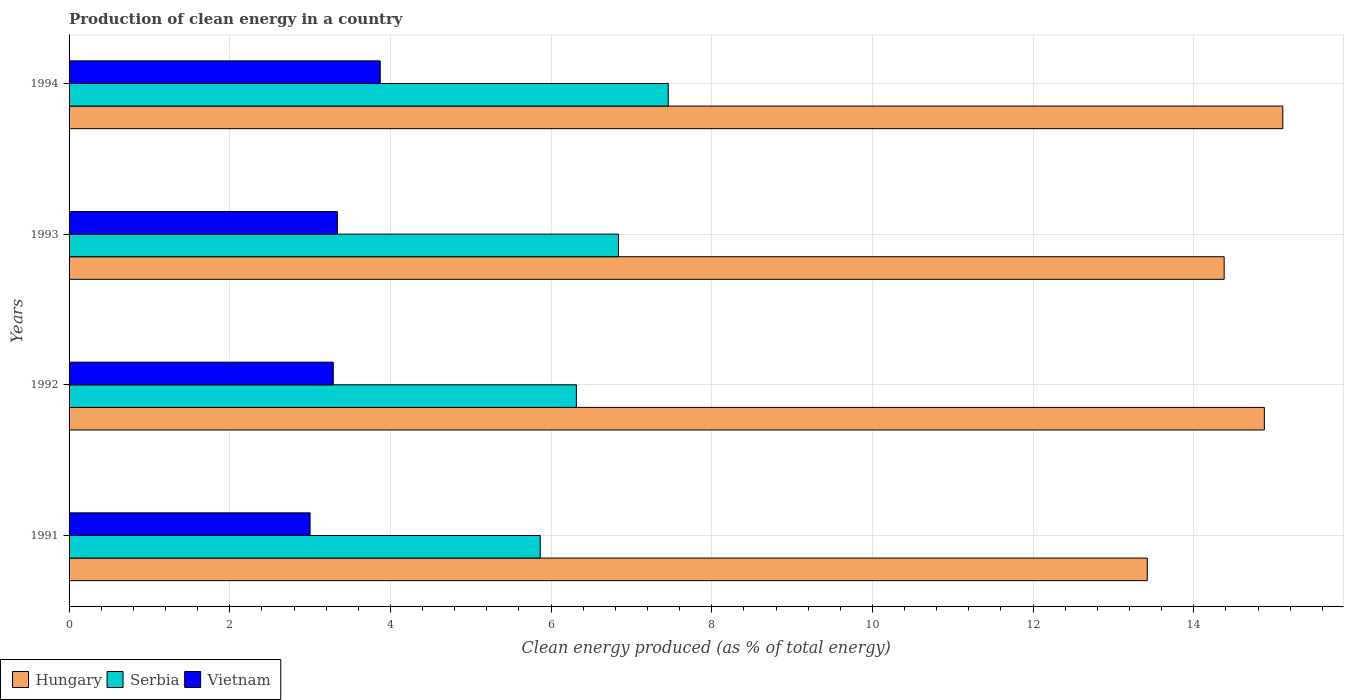Are the number of bars per tick equal to the number of legend labels?
Ensure brevity in your answer.  Yes. Are the number of bars on each tick of the Y-axis equal?
Ensure brevity in your answer.  Yes. How many bars are there on the 4th tick from the bottom?
Ensure brevity in your answer.  3. In how many cases, is the number of bars for a given year not equal to the number of legend labels?
Offer a terse response. 0. What is the percentage of clean energy produced in Serbia in 1992?
Provide a succinct answer. 6.32. Across all years, what is the maximum percentage of clean energy produced in Hungary?
Make the answer very short. 15.11. Across all years, what is the minimum percentage of clean energy produced in Serbia?
Make the answer very short. 5.87. What is the total percentage of clean energy produced in Vietnam in the graph?
Make the answer very short. 13.5. What is the difference between the percentage of clean energy produced in Serbia in 1992 and that in 1993?
Offer a very short reply. -0.52. What is the difference between the percentage of clean energy produced in Vietnam in 1992 and the percentage of clean energy produced in Serbia in 1993?
Offer a terse response. -3.55. What is the average percentage of clean energy produced in Vietnam per year?
Offer a terse response. 3.38. In the year 1993, what is the difference between the percentage of clean energy produced in Serbia and percentage of clean energy produced in Hungary?
Provide a short and direct response. -7.54. What is the ratio of the percentage of clean energy produced in Serbia in 1991 to that in 1992?
Your answer should be very brief. 0.93. Is the difference between the percentage of clean energy produced in Serbia in 1992 and 1993 greater than the difference between the percentage of clean energy produced in Hungary in 1992 and 1993?
Your answer should be very brief. No. What is the difference between the highest and the second highest percentage of clean energy produced in Hungary?
Your response must be concise. 0.23. What is the difference between the highest and the lowest percentage of clean energy produced in Serbia?
Keep it short and to the point. 1.59. Is the sum of the percentage of clean energy produced in Serbia in 1992 and 1993 greater than the maximum percentage of clean energy produced in Vietnam across all years?
Make the answer very short. Yes. What does the 1st bar from the top in 1992 represents?
Offer a terse response. Vietnam. What does the 1st bar from the bottom in 1991 represents?
Offer a very short reply. Hungary. Is it the case that in every year, the sum of the percentage of clean energy produced in Serbia and percentage of clean energy produced in Vietnam is greater than the percentage of clean energy produced in Hungary?
Provide a succinct answer. No. Are all the bars in the graph horizontal?
Ensure brevity in your answer.  Yes. How many years are there in the graph?
Your answer should be compact. 4. Are the values on the major ticks of X-axis written in scientific E-notation?
Offer a very short reply. No. Does the graph contain any zero values?
Offer a terse response. No. How many legend labels are there?
Provide a short and direct response. 3. How are the legend labels stacked?
Give a very brief answer. Horizontal. What is the title of the graph?
Your response must be concise. Production of clean energy in a country. Does "Brazil" appear as one of the legend labels in the graph?
Provide a succinct answer. No. What is the label or title of the X-axis?
Your answer should be compact. Clean energy produced (as % of total energy). What is the label or title of the Y-axis?
Offer a terse response. Years. What is the Clean energy produced (as % of total energy) of Hungary in 1991?
Offer a very short reply. 13.42. What is the Clean energy produced (as % of total energy) of Serbia in 1991?
Keep it short and to the point. 5.87. What is the Clean energy produced (as % of total energy) of Vietnam in 1991?
Keep it short and to the point. 3. What is the Clean energy produced (as % of total energy) in Hungary in 1992?
Ensure brevity in your answer.  14.88. What is the Clean energy produced (as % of total energy) in Serbia in 1992?
Offer a terse response. 6.32. What is the Clean energy produced (as % of total energy) of Vietnam in 1992?
Keep it short and to the point. 3.29. What is the Clean energy produced (as % of total energy) of Hungary in 1993?
Make the answer very short. 14.38. What is the Clean energy produced (as % of total energy) of Serbia in 1993?
Your response must be concise. 6.84. What is the Clean energy produced (as % of total energy) of Vietnam in 1993?
Your response must be concise. 3.34. What is the Clean energy produced (as % of total energy) in Hungary in 1994?
Provide a succinct answer. 15.11. What is the Clean energy produced (as % of total energy) in Serbia in 1994?
Ensure brevity in your answer.  7.46. What is the Clean energy produced (as % of total energy) in Vietnam in 1994?
Ensure brevity in your answer.  3.87. Across all years, what is the maximum Clean energy produced (as % of total energy) of Hungary?
Make the answer very short. 15.11. Across all years, what is the maximum Clean energy produced (as % of total energy) in Serbia?
Make the answer very short. 7.46. Across all years, what is the maximum Clean energy produced (as % of total energy) in Vietnam?
Your response must be concise. 3.87. Across all years, what is the minimum Clean energy produced (as % of total energy) of Hungary?
Your response must be concise. 13.42. Across all years, what is the minimum Clean energy produced (as % of total energy) of Serbia?
Your answer should be compact. 5.87. Across all years, what is the minimum Clean energy produced (as % of total energy) in Vietnam?
Provide a short and direct response. 3. What is the total Clean energy produced (as % of total energy) of Hungary in the graph?
Provide a short and direct response. 57.79. What is the total Clean energy produced (as % of total energy) of Serbia in the graph?
Your response must be concise. 26.48. What is the total Clean energy produced (as % of total energy) in Vietnam in the graph?
Keep it short and to the point. 13.5. What is the difference between the Clean energy produced (as % of total energy) of Hungary in 1991 and that in 1992?
Offer a very short reply. -1.46. What is the difference between the Clean energy produced (as % of total energy) in Serbia in 1991 and that in 1992?
Your response must be concise. -0.45. What is the difference between the Clean energy produced (as % of total energy) of Vietnam in 1991 and that in 1992?
Make the answer very short. -0.29. What is the difference between the Clean energy produced (as % of total energy) of Hungary in 1991 and that in 1993?
Your answer should be very brief. -0.96. What is the difference between the Clean energy produced (as % of total energy) in Serbia in 1991 and that in 1993?
Your answer should be compact. -0.97. What is the difference between the Clean energy produced (as % of total energy) of Vietnam in 1991 and that in 1993?
Your response must be concise. -0.34. What is the difference between the Clean energy produced (as % of total energy) in Hungary in 1991 and that in 1994?
Make the answer very short. -1.69. What is the difference between the Clean energy produced (as % of total energy) of Serbia in 1991 and that in 1994?
Your response must be concise. -1.59. What is the difference between the Clean energy produced (as % of total energy) in Vietnam in 1991 and that in 1994?
Ensure brevity in your answer.  -0.87. What is the difference between the Clean energy produced (as % of total energy) in Hungary in 1992 and that in 1993?
Offer a terse response. 0.5. What is the difference between the Clean energy produced (as % of total energy) of Serbia in 1992 and that in 1993?
Make the answer very short. -0.52. What is the difference between the Clean energy produced (as % of total energy) in Vietnam in 1992 and that in 1993?
Give a very brief answer. -0.05. What is the difference between the Clean energy produced (as % of total energy) of Hungary in 1992 and that in 1994?
Offer a terse response. -0.23. What is the difference between the Clean energy produced (as % of total energy) in Serbia in 1992 and that in 1994?
Provide a short and direct response. -1.14. What is the difference between the Clean energy produced (as % of total energy) of Vietnam in 1992 and that in 1994?
Your answer should be compact. -0.58. What is the difference between the Clean energy produced (as % of total energy) of Hungary in 1993 and that in 1994?
Keep it short and to the point. -0.73. What is the difference between the Clean energy produced (as % of total energy) of Serbia in 1993 and that in 1994?
Offer a terse response. -0.62. What is the difference between the Clean energy produced (as % of total energy) in Vietnam in 1993 and that in 1994?
Ensure brevity in your answer.  -0.53. What is the difference between the Clean energy produced (as % of total energy) of Hungary in 1991 and the Clean energy produced (as % of total energy) of Serbia in 1992?
Your response must be concise. 7.11. What is the difference between the Clean energy produced (as % of total energy) of Hungary in 1991 and the Clean energy produced (as % of total energy) of Vietnam in 1992?
Keep it short and to the point. 10.13. What is the difference between the Clean energy produced (as % of total energy) in Serbia in 1991 and the Clean energy produced (as % of total energy) in Vietnam in 1992?
Offer a very short reply. 2.58. What is the difference between the Clean energy produced (as % of total energy) of Hungary in 1991 and the Clean energy produced (as % of total energy) of Serbia in 1993?
Your answer should be very brief. 6.58. What is the difference between the Clean energy produced (as % of total energy) in Hungary in 1991 and the Clean energy produced (as % of total energy) in Vietnam in 1993?
Your answer should be very brief. 10.08. What is the difference between the Clean energy produced (as % of total energy) in Serbia in 1991 and the Clean energy produced (as % of total energy) in Vietnam in 1993?
Keep it short and to the point. 2.53. What is the difference between the Clean energy produced (as % of total energy) of Hungary in 1991 and the Clean energy produced (as % of total energy) of Serbia in 1994?
Offer a terse response. 5.96. What is the difference between the Clean energy produced (as % of total energy) in Hungary in 1991 and the Clean energy produced (as % of total energy) in Vietnam in 1994?
Ensure brevity in your answer.  9.55. What is the difference between the Clean energy produced (as % of total energy) of Serbia in 1991 and the Clean energy produced (as % of total energy) of Vietnam in 1994?
Make the answer very short. 1.99. What is the difference between the Clean energy produced (as % of total energy) in Hungary in 1992 and the Clean energy produced (as % of total energy) in Serbia in 1993?
Offer a very short reply. 8.04. What is the difference between the Clean energy produced (as % of total energy) of Hungary in 1992 and the Clean energy produced (as % of total energy) of Vietnam in 1993?
Make the answer very short. 11.54. What is the difference between the Clean energy produced (as % of total energy) in Serbia in 1992 and the Clean energy produced (as % of total energy) in Vietnam in 1993?
Keep it short and to the point. 2.98. What is the difference between the Clean energy produced (as % of total energy) of Hungary in 1992 and the Clean energy produced (as % of total energy) of Serbia in 1994?
Provide a short and direct response. 7.42. What is the difference between the Clean energy produced (as % of total energy) in Hungary in 1992 and the Clean energy produced (as % of total energy) in Vietnam in 1994?
Ensure brevity in your answer.  11.01. What is the difference between the Clean energy produced (as % of total energy) in Serbia in 1992 and the Clean energy produced (as % of total energy) in Vietnam in 1994?
Your response must be concise. 2.44. What is the difference between the Clean energy produced (as % of total energy) in Hungary in 1993 and the Clean energy produced (as % of total energy) in Serbia in 1994?
Ensure brevity in your answer.  6.92. What is the difference between the Clean energy produced (as % of total energy) in Hungary in 1993 and the Clean energy produced (as % of total energy) in Vietnam in 1994?
Keep it short and to the point. 10.51. What is the difference between the Clean energy produced (as % of total energy) in Serbia in 1993 and the Clean energy produced (as % of total energy) in Vietnam in 1994?
Provide a succinct answer. 2.97. What is the average Clean energy produced (as % of total energy) in Hungary per year?
Provide a short and direct response. 14.45. What is the average Clean energy produced (as % of total energy) in Serbia per year?
Your answer should be very brief. 6.62. What is the average Clean energy produced (as % of total energy) in Vietnam per year?
Keep it short and to the point. 3.38. In the year 1991, what is the difference between the Clean energy produced (as % of total energy) of Hungary and Clean energy produced (as % of total energy) of Serbia?
Make the answer very short. 7.56. In the year 1991, what is the difference between the Clean energy produced (as % of total energy) in Hungary and Clean energy produced (as % of total energy) in Vietnam?
Offer a terse response. 10.42. In the year 1991, what is the difference between the Clean energy produced (as % of total energy) in Serbia and Clean energy produced (as % of total energy) in Vietnam?
Make the answer very short. 2.87. In the year 1992, what is the difference between the Clean energy produced (as % of total energy) of Hungary and Clean energy produced (as % of total energy) of Serbia?
Make the answer very short. 8.56. In the year 1992, what is the difference between the Clean energy produced (as % of total energy) in Hungary and Clean energy produced (as % of total energy) in Vietnam?
Make the answer very short. 11.59. In the year 1992, what is the difference between the Clean energy produced (as % of total energy) in Serbia and Clean energy produced (as % of total energy) in Vietnam?
Your answer should be compact. 3.03. In the year 1993, what is the difference between the Clean energy produced (as % of total energy) of Hungary and Clean energy produced (as % of total energy) of Serbia?
Offer a very short reply. 7.54. In the year 1993, what is the difference between the Clean energy produced (as % of total energy) of Hungary and Clean energy produced (as % of total energy) of Vietnam?
Make the answer very short. 11.04. In the year 1993, what is the difference between the Clean energy produced (as % of total energy) in Serbia and Clean energy produced (as % of total energy) in Vietnam?
Make the answer very short. 3.5. In the year 1994, what is the difference between the Clean energy produced (as % of total energy) of Hungary and Clean energy produced (as % of total energy) of Serbia?
Provide a short and direct response. 7.65. In the year 1994, what is the difference between the Clean energy produced (as % of total energy) of Hungary and Clean energy produced (as % of total energy) of Vietnam?
Keep it short and to the point. 11.24. In the year 1994, what is the difference between the Clean energy produced (as % of total energy) in Serbia and Clean energy produced (as % of total energy) in Vietnam?
Give a very brief answer. 3.59. What is the ratio of the Clean energy produced (as % of total energy) in Hungary in 1991 to that in 1992?
Provide a succinct answer. 0.9. What is the ratio of the Clean energy produced (as % of total energy) of Serbia in 1991 to that in 1992?
Provide a succinct answer. 0.93. What is the ratio of the Clean energy produced (as % of total energy) of Vietnam in 1991 to that in 1992?
Offer a terse response. 0.91. What is the ratio of the Clean energy produced (as % of total energy) in Hungary in 1991 to that in 1993?
Keep it short and to the point. 0.93. What is the ratio of the Clean energy produced (as % of total energy) in Serbia in 1991 to that in 1993?
Ensure brevity in your answer.  0.86. What is the ratio of the Clean energy produced (as % of total energy) in Vietnam in 1991 to that in 1993?
Provide a short and direct response. 0.9. What is the ratio of the Clean energy produced (as % of total energy) in Hungary in 1991 to that in 1994?
Provide a succinct answer. 0.89. What is the ratio of the Clean energy produced (as % of total energy) in Serbia in 1991 to that in 1994?
Your answer should be compact. 0.79. What is the ratio of the Clean energy produced (as % of total energy) of Vietnam in 1991 to that in 1994?
Your answer should be compact. 0.77. What is the ratio of the Clean energy produced (as % of total energy) of Hungary in 1992 to that in 1993?
Your response must be concise. 1.03. What is the ratio of the Clean energy produced (as % of total energy) of Serbia in 1992 to that in 1993?
Keep it short and to the point. 0.92. What is the ratio of the Clean energy produced (as % of total energy) of Vietnam in 1992 to that in 1993?
Your answer should be compact. 0.98. What is the ratio of the Clean energy produced (as % of total energy) in Serbia in 1992 to that in 1994?
Provide a succinct answer. 0.85. What is the ratio of the Clean energy produced (as % of total energy) of Vietnam in 1992 to that in 1994?
Your answer should be very brief. 0.85. What is the ratio of the Clean energy produced (as % of total energy) of Hungary in 1993 to that in 1994?
Make the answer very short. 0.95. What is the ratio of the Clean energy produced (as % of total energy) of Serbia in 1993 to that in 1994?
Your answer should be compact. 0.92. What is the ratio of the Clean energy produced (as % of total energy) of Vietnam in 1993 to that in 1994?
Keep it short and to the point. 0.86. What is the difference between the highest and the second highest Clean energy produced (as % of total energy) in Hungary?
Provide a succinct answer. 0.23. What is the difference between the highest and the second highest Clean energy produced (as % of total energy) of Serbia?
Make the answer very short. 0.62. What is the difference between the highest and the second highest Clean energy produced (as % of total energy) in Vietnam?
Provide a succinct answer. 0.53. What is the difference between the highest and the lowest Clean energy produced (as % of total energy) in Hungary?
Offer a very short reply. 1.69. What is the difference between the highest and the lowest Clean energy produced (as % of total energy) of Serbia?
Ensure brevity in your answer.  1.59. What is the difference between the highest and the lowest Clean energy produced (as % of total energy) in Vietnam?
Your response must be concise. 0.87. 